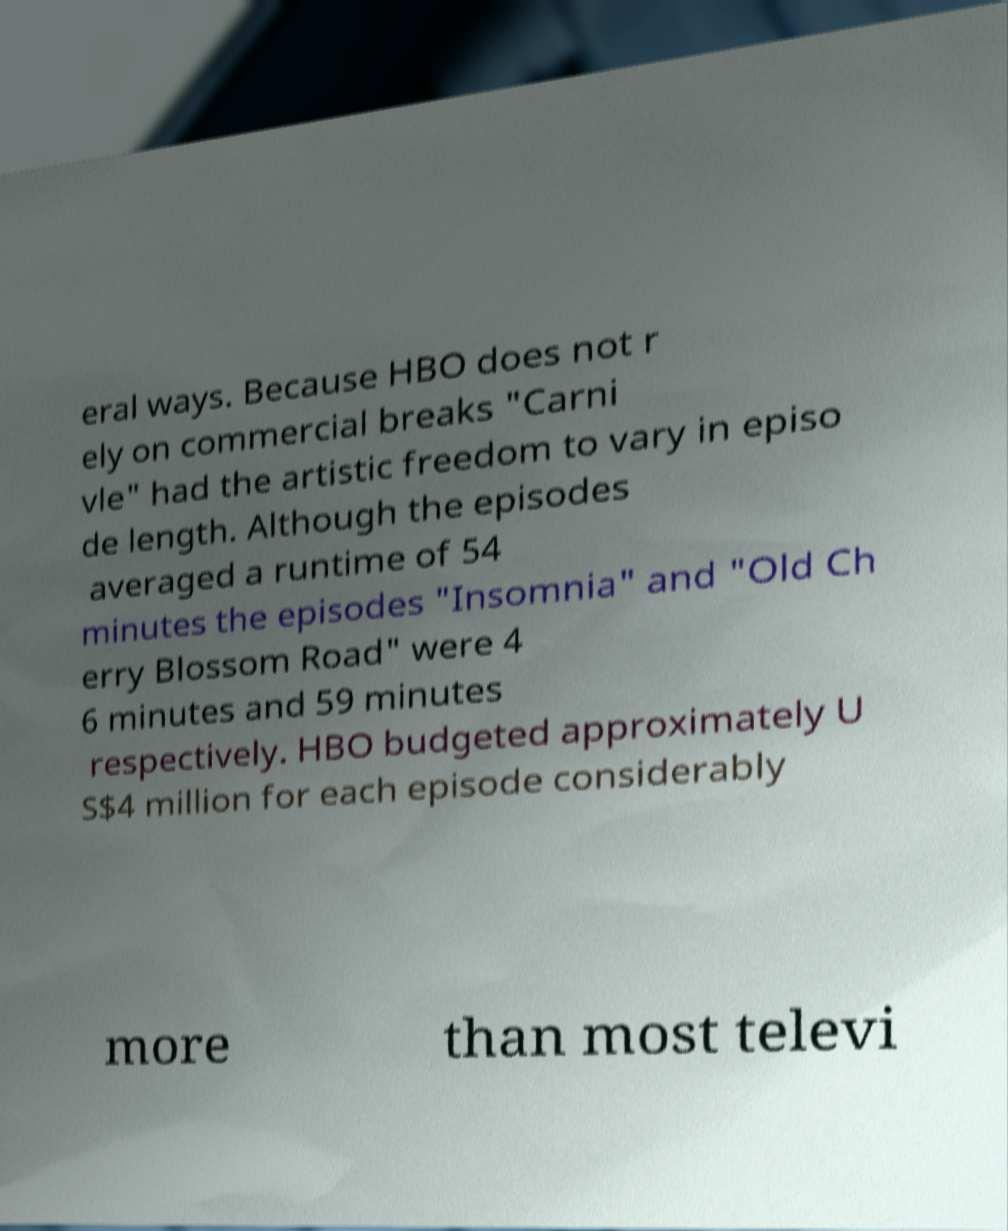Could you assist in decoding the text presented in this image and type it out clearly? eral ways. Because HBO does not r ely on commercial breaks "Carni vle" had the artistic freedom to vary in episo de length. Although the episodes averaged a runtime of 54 minutes the episodes "Insomnia" and "Old Ch erry Blossom Road" were 4 6 minutes and 59 minutes respectively. HBO budgeted approximately U S$4 million for each episode considerably more than most televi 